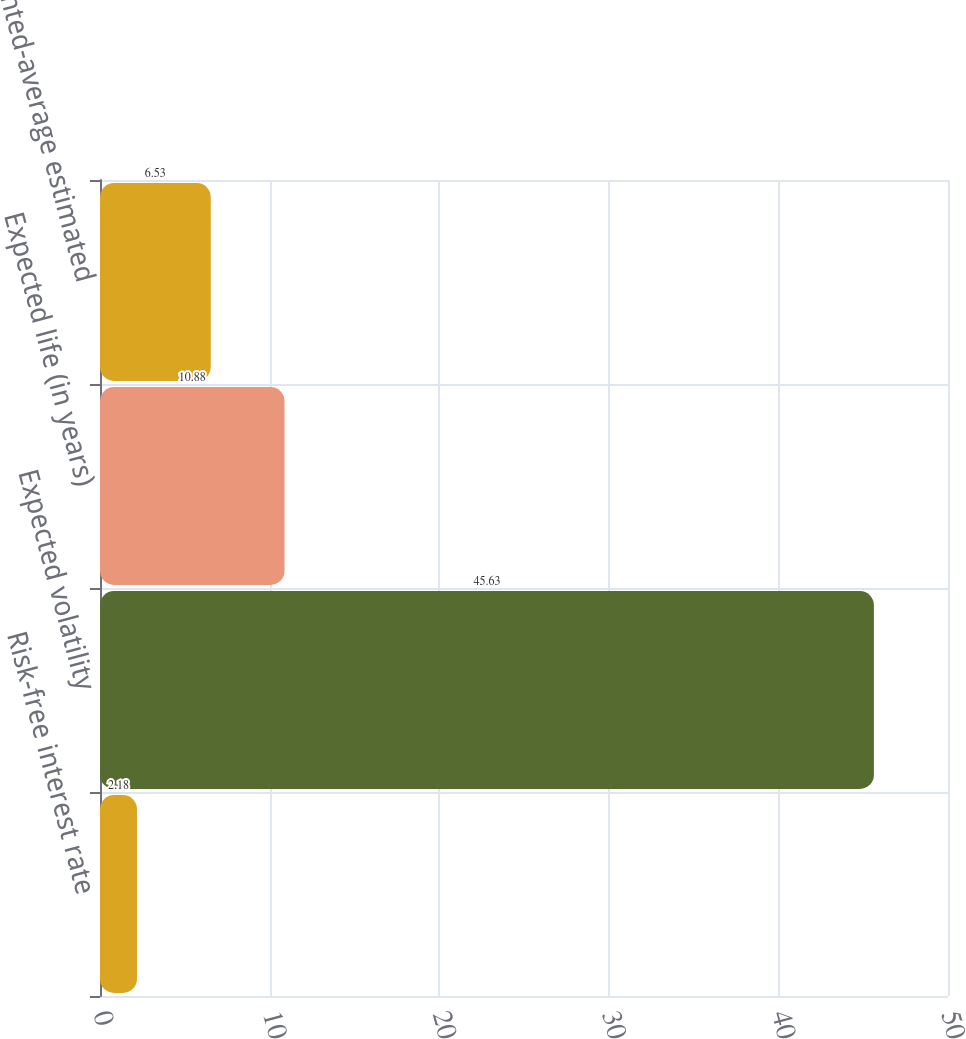Convert chart to OTSL. <chart><loc_0><loc_0><loc_500><loc_500><bar_chart><fcel>Risk-free interest rate<fcel>Expected volatility<fcel>Expected life (in years)<fcel>Weighted-average estimated<nl><fcel>2.18<fcel>45.63<fcel>10.88<fcel>6.53<nl></chart> 